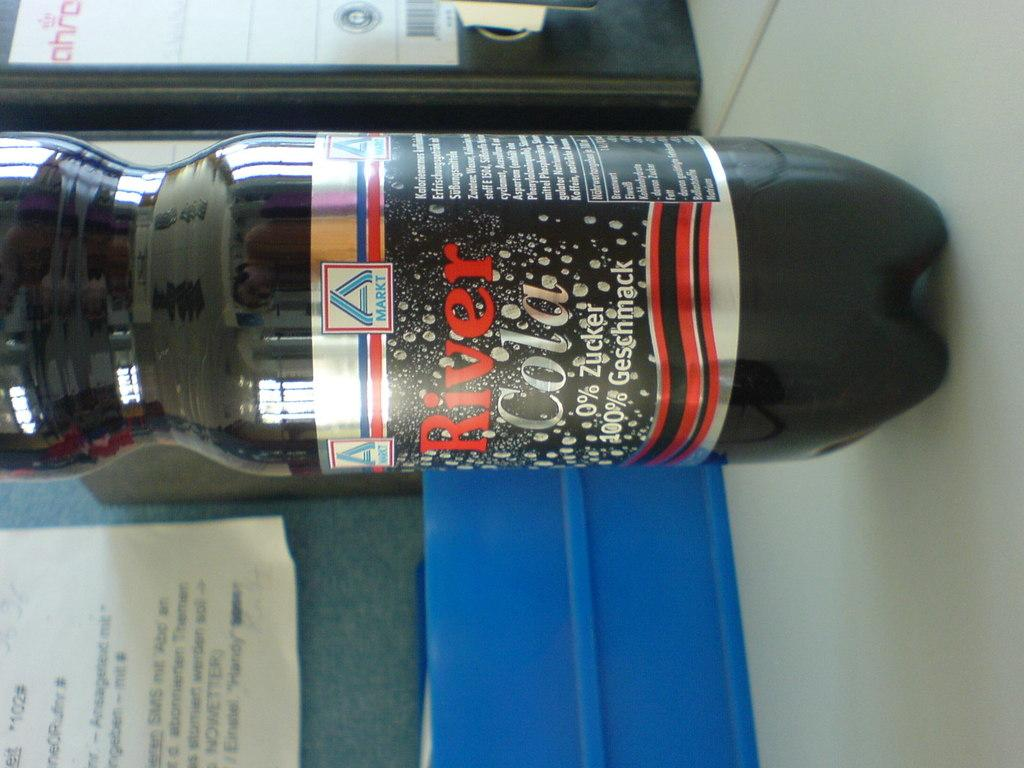<image>
Relay a brief, clear account of the picture shown. A bottle of River Cola is sitting on light colored surface. 